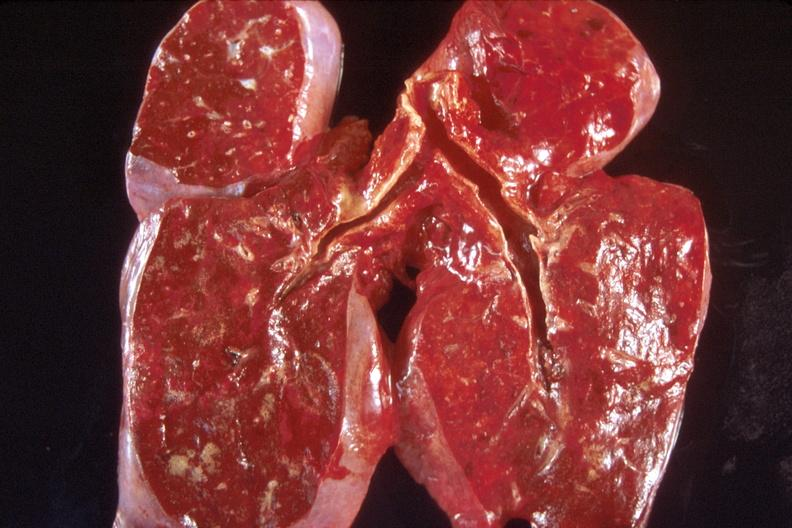where is this?
Answer the question using a single word or phrase. Lung 